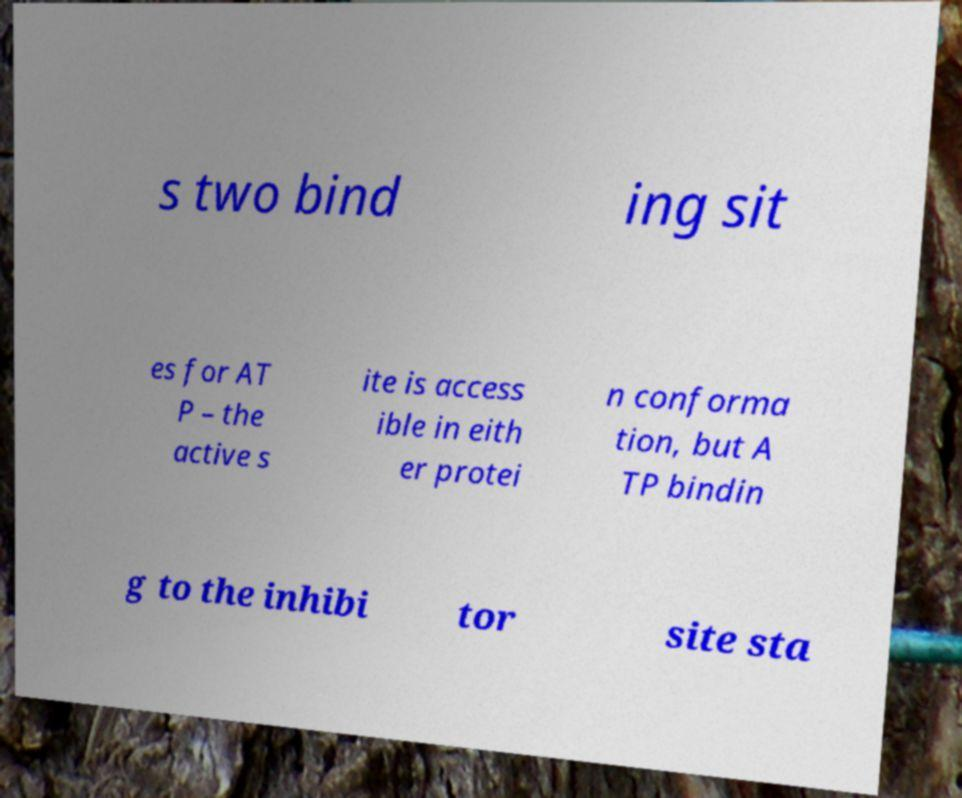What messages or text are displayed in this image? I need them in a readable, typed format. s two bind ing sit es for AT P – the active s ite is access ible in eith er protei n conforma tion, but A TP bindin g to the inhibi tor site sta 